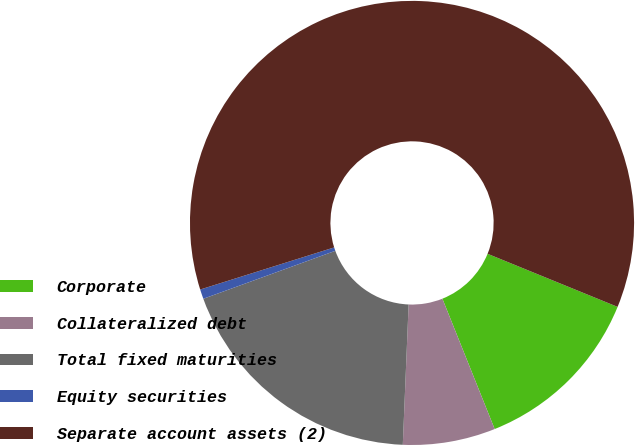Convert chart. <chart><loc_0><loc_0><loc_500><loc_500><pie_chart><fcel>Corporate<fcel>Collateralized debt<fcel>Total fixed maturities<fcel>Equity securities<fcel>Separate account assets (2)<nl><fcel>12.76%<fcel>6.73%<fcel>18.79%<fcel>0.7%<fcel>61.01%<nl></chart> 